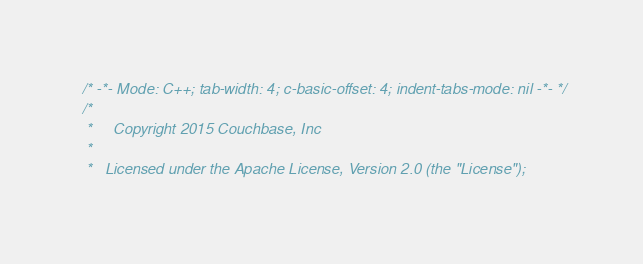Convert code to text. <code><loc_0><loc_0><loc_500><loc_500><_C++_>/* -*- Mode: C++; tab-width: 4; c-basic-offset: 4; indent-tabs-mode: nil -*- */
/*
 *     Copyright 2015 Couchbase, Inc
 *
 *   Licensed under the Apache License, Version 2.0 (the "License");</code> 